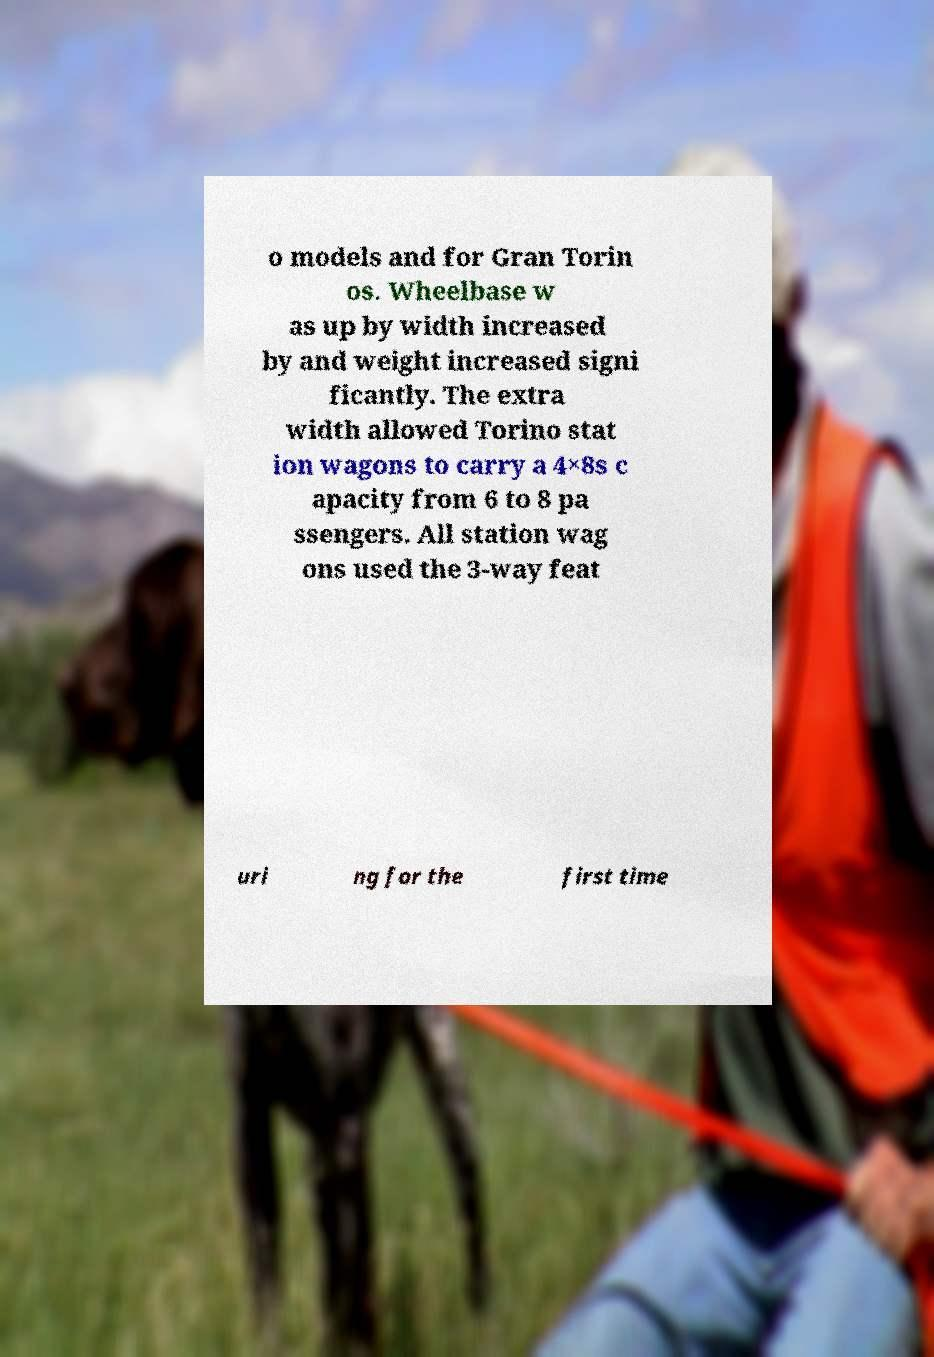Can you read and provide the text displayed in the image?This photo seems to have some interesting text. Can you extract and type it out for me? o models and for Gran Torin os. Wheelbase w as up by width increased by and weight increased signi ficantly. The extra width allowed Torino stat ion wagons to carry a 4×8s c apacity from 6 to 8 pa ssengers. All station wag ons used the 3-way feat uri ng for the first time 